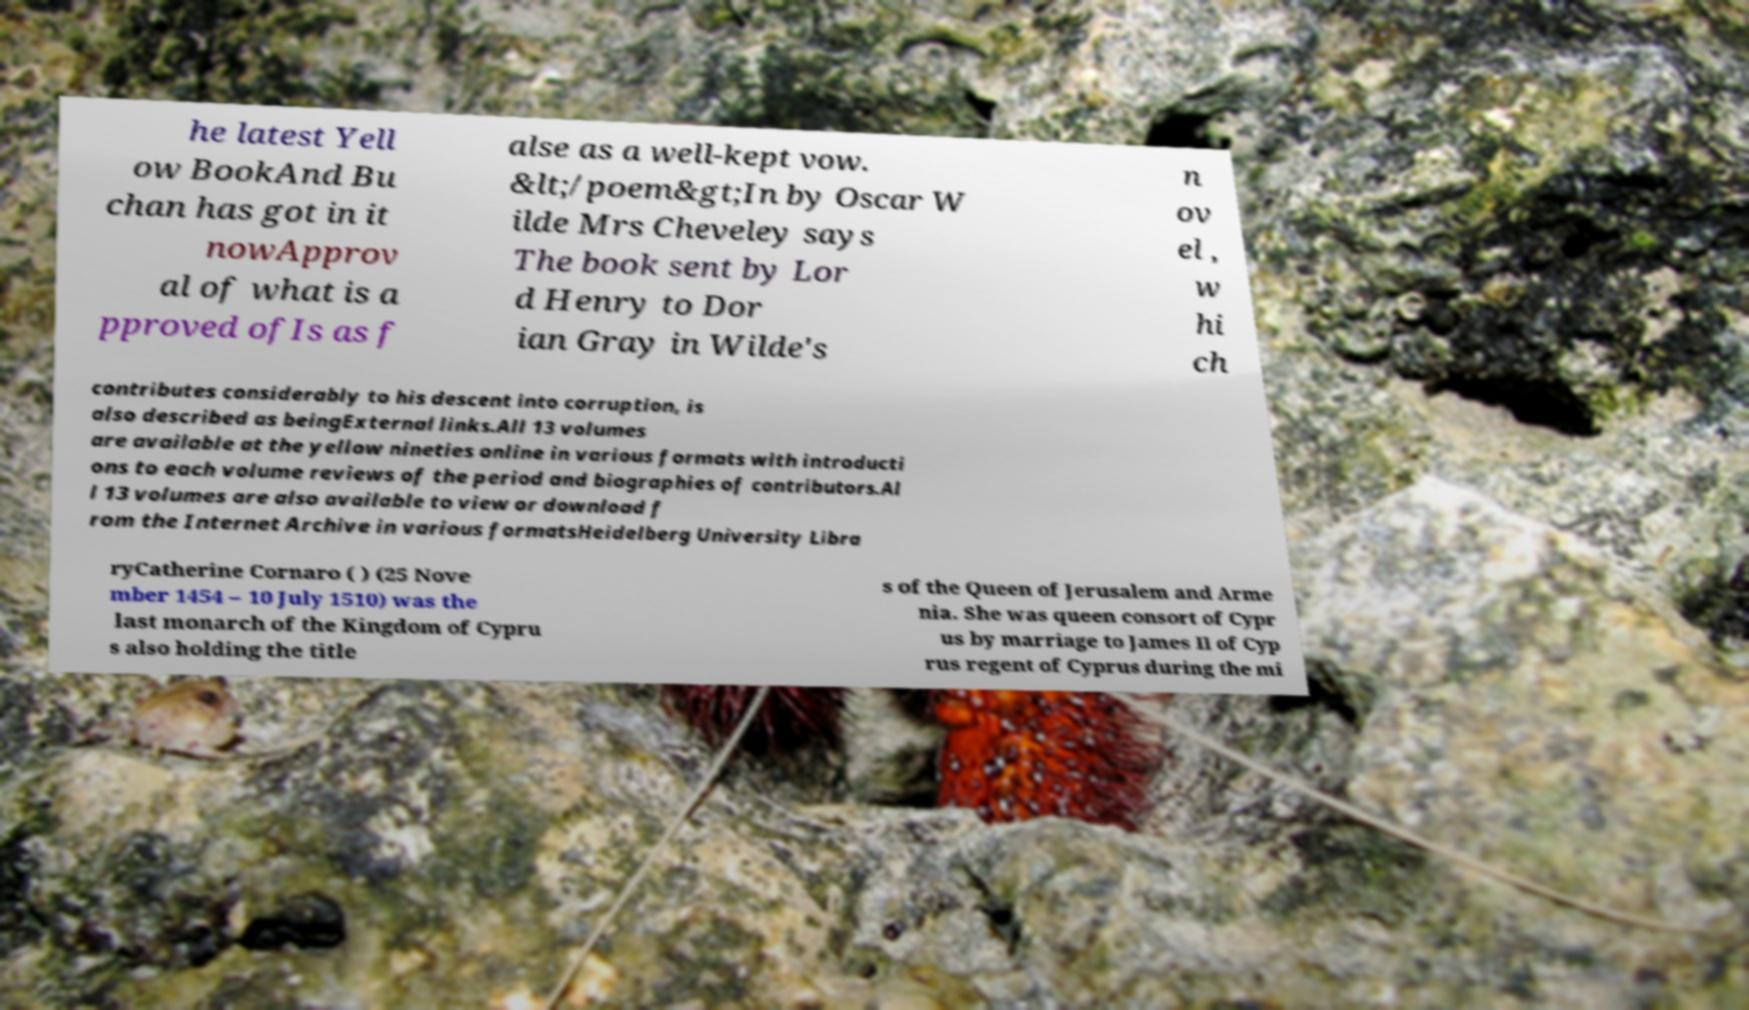I need the written content from this picture converted into text. Can you do that? he latest Yell ow BookAnd Bu chan has got in it nowApprov al of what is a pproved ofIs as f alse as a well-kept vow. &lt;/poem&gt;In by Oscar W ilde Mrs Cheveley says The book sent by Lor d Henry to Dor ian Gray in Wilde's n ov el , w hi ch contributes considerably to his descent into corruption, is also described as beingExternal links.All 13 volumes are available at the yellow nineties online in various formats with introducti ons to each volume reviews of the period and biographies of contributors.Al l 13 volumes are also available to view or download f rom the Internet Archive in various formatsHeidelberg University Libra ryCatherine Cornaro ( ) (25 Nove mber 1454 – 10 July 1510) was the last monarch of the Kingdom of Cypru s also holding the title s of the Queen of Jerusalem and Arme nia. She was queen consort of Cypr us by marriage to James II of Cyp rus regent of Cyprus during the mi 